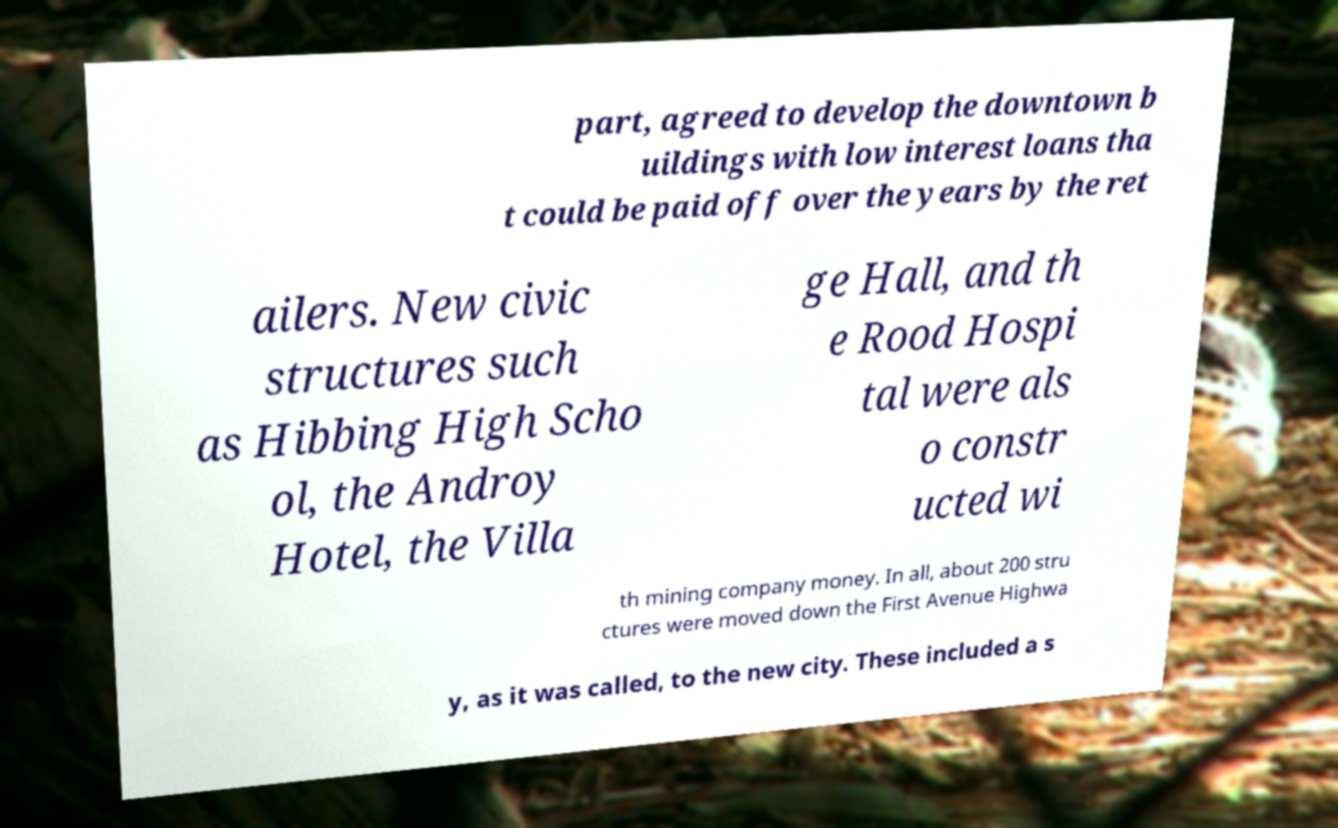What messages or text are displayed in this image? I need them in a readable, typed format. part, agreed to develop the downtown b uildings with low interest loans tha t could be paid off over the years by the ret ailers. New civic structures such as Hibbing High Scho ol, the Androy Hotel, the Villa ge Hall, and th e Rood Hospi tal were als o constr ucted wi th mining company money. In all, about 200 stru ctures were moved down the First Avenue Highwa y, as it was called, to the new city. These included a s 